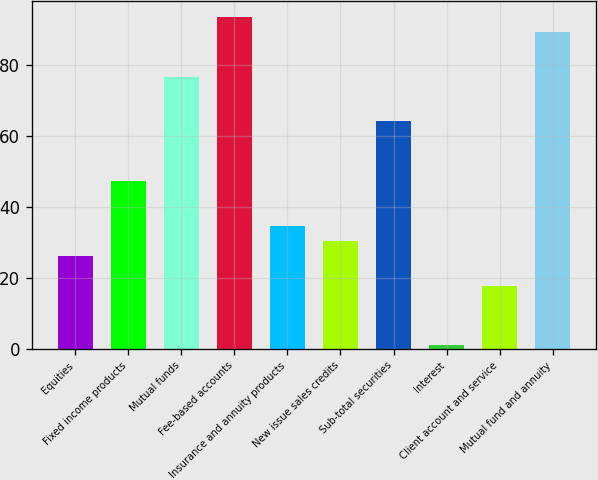Convert chart to OTSL. <chart><loc_0><loc_0><loc_500><loc_500><bar_chart><fcel>Equities<fcel>Fixed income products<fcel>Mutual funds<fcel>Fee-based accounts<fcel>Insurance and annuity products<fcel>New issue sales credits<fcel>Sub-total securities<fcel>Interest<fcel>Client account and service<fcel>Mutual fund and annuity<nl><fcel>26.2<fcel>47.2<fcel>76.6<fcel>93.4<fcel>34.6<fcel>30.4<fcel>64<fcel>1<fcel>17.8<fcel>89.2<nl></chart> 